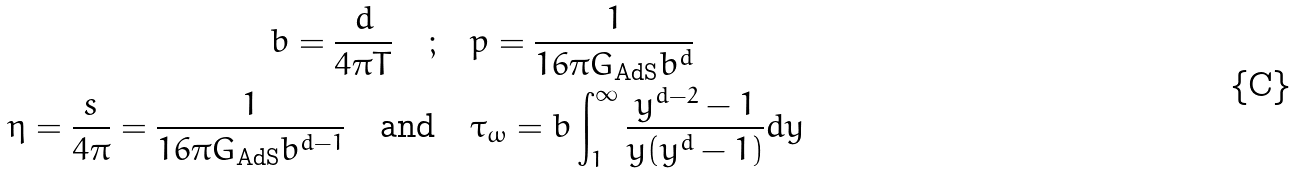<formula> <loc_0><loc_0><loc_500><loc_500>b = \frac { d } { 4 \pi T } \quad ; & \quad p = \frac { 1 } { 1 6 \pi G _ { \text {AdS} } b ^ { d } } \\ \eta = \frac { s } { 4 \pi } = \frac { 1 } { 1 6 \pi G _ { \text {AdS} } b ^ { d - 1 } } \quad \text {and} & \quad \tau _ { \omega } = b \int _ { 1 } ^ { \infty } \frac { y ^ { d - 2 } - 1 } { y ( y ^ { d } - 1 ) } d y</formula> 